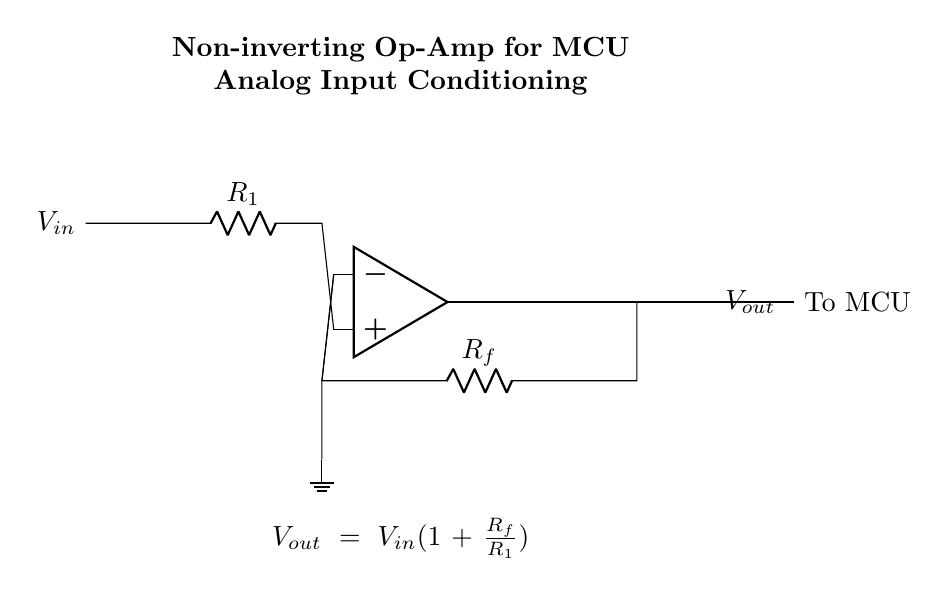What type of operational amplifier configuration is shown? The circuit diagram depicts a non-inverting operational amplifier configuration, which is characterized by the input being applied to the non-inverting terminal of the op-amp.
Answer: Non-inverting What are the resistor values in the feedback and input paths? The feedback resistor is denoted as Rf, and the input resistor is identified as R1 in the circuit diagram. Their actual values would depend on the specific circuit implementation, but they are represented generically here.
Answer: R1 and Rf What is the formula for the output voltage? The output voltage formula is given in the equation below the circuit diagram, which is Vout = Vin(1 + Rf/R1). This indicates how the output voltage relates to the input voltage and the resistor values.
Answer: Vout = Vin(1 + Rf/R1) What role does the input node play in this circuit? The input node is where the input voltage Vin is applied. It connects through the resistor R1 to the non-inverting terminal of the op-amp, which is crucial for the signal amplification process.
Answer: Input for Vin How does the feedback resistor impact the gain of the amplifier? The feedback resistor Rf influences the gain of the operational amplifier circuit. A larger value of Rf relative to R1 increases the gain, as shown in the output voltage formula. This interaction determines how much the input signal is amplified.
Answer: Increases gain What is the purpose of grounding in this circuit? Grounding provides a reference point for all voltages in the circuit. It stabilizes the circuit operation and ensures that the voltages are measured relative to a common point, which is essential for the accurate functioning of the op-amp.
Answer: Reference point 